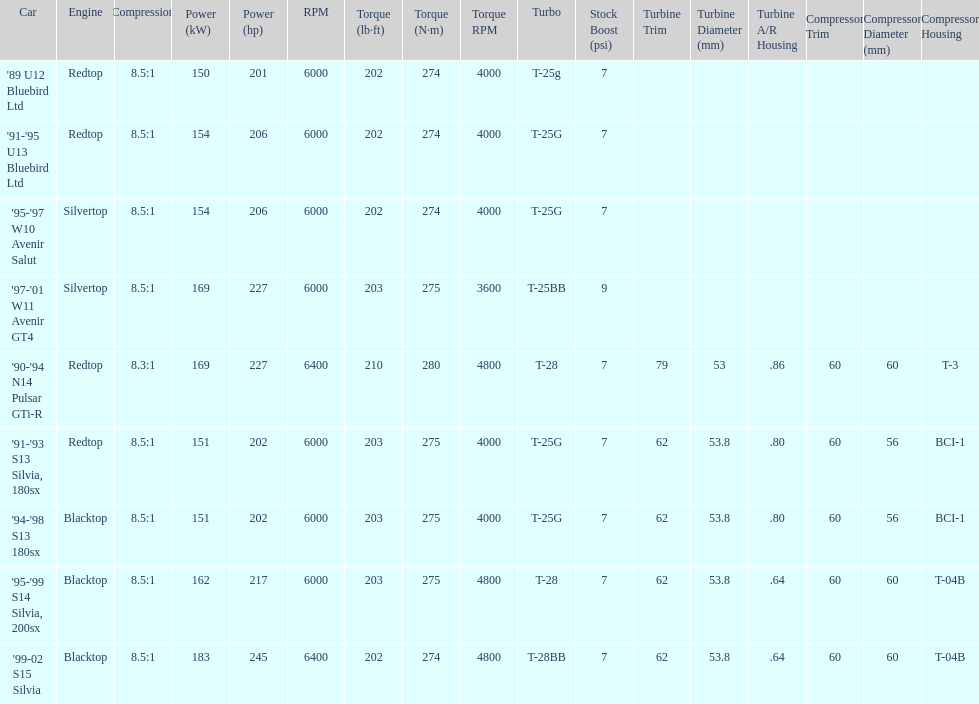Which engine(s) has the least amount of power? Redtop. 